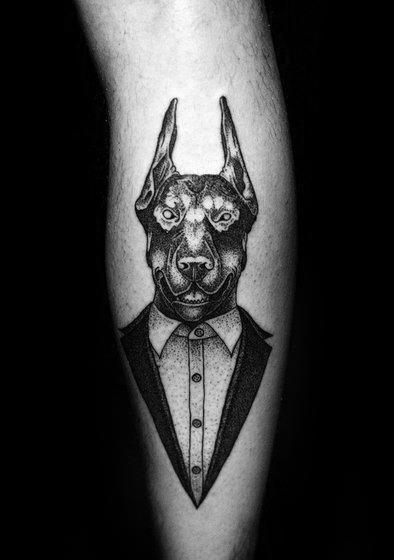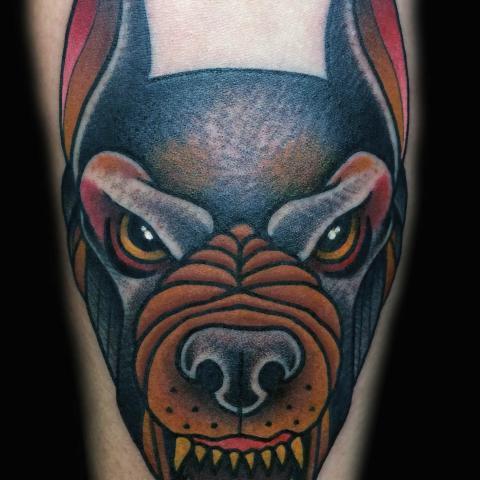The first image is the image on the left, the second image is the image on the right. Analyze the images presented: Is the assertion "The left and right image contains the same number of dog head tattoos." valid? Answer yes or no. Yes. The first image is the image on the left, the second image is the image on the right. Evaluate the accuracy of this statement regarding the images: "In both drawings the doberman's mouth is open.". Is it true? Answer yes or no. Yes. 